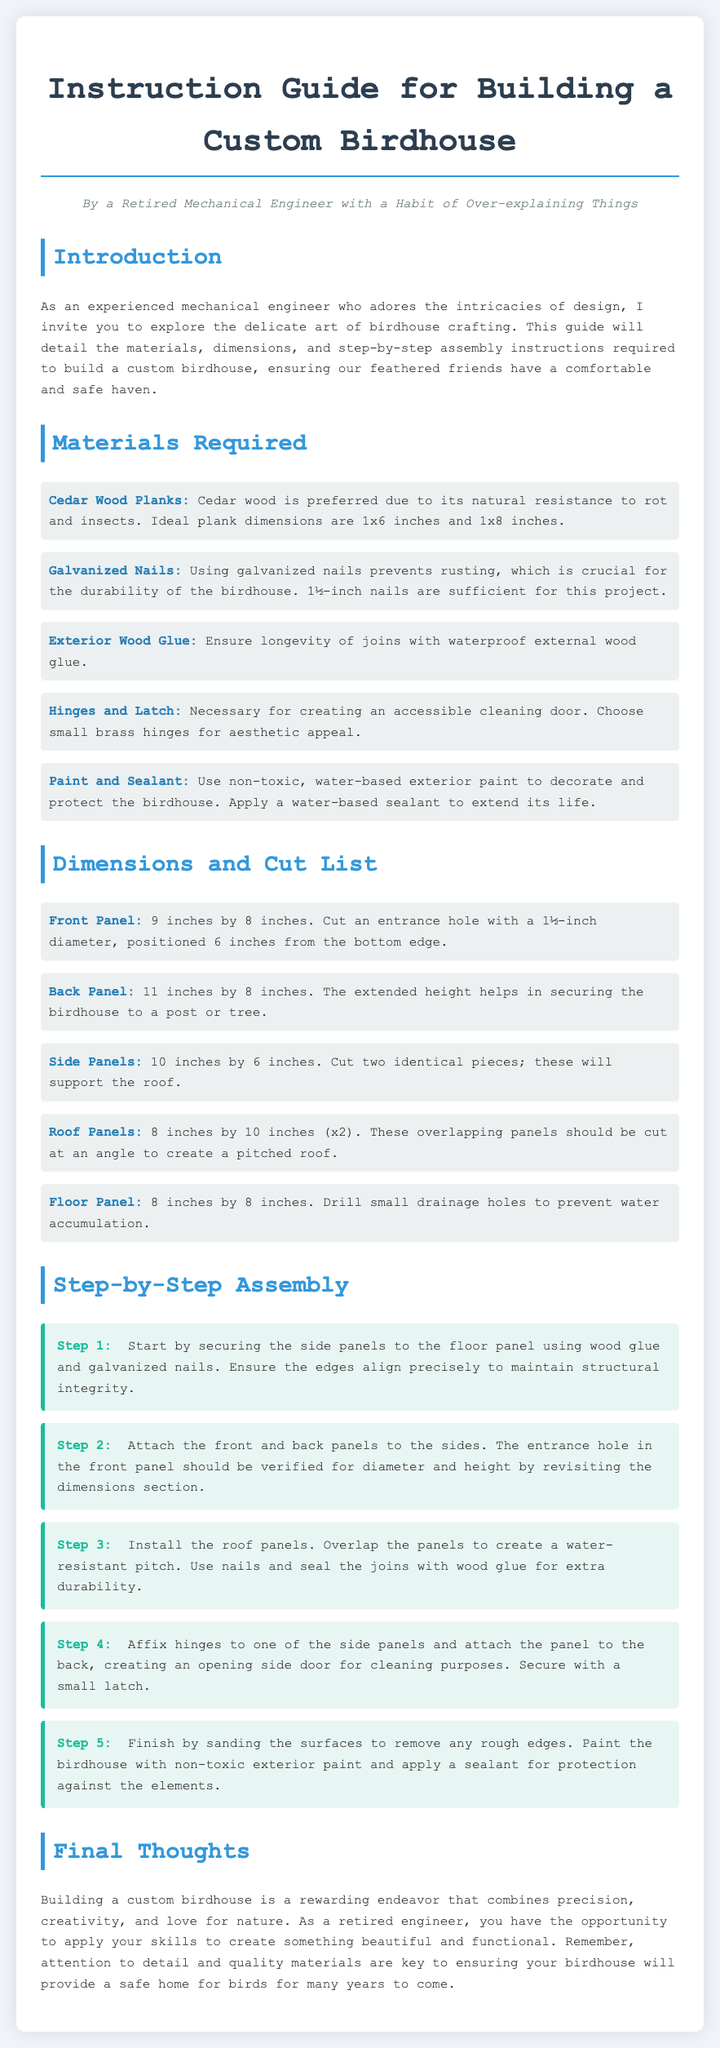what is the recommended wood type for the birdhouse? The document states that cedar wood is preferred due to its natural resistance to rot and insects.
Answer: Cedar Wood Planks how many hinges are suggested for the birdhouse? The guide mentions using small brass hinges for the accessible cleaning door, but does not specify a quantity.
Answer: Hinges what is the diameter of the entrance hole in the front panel? The dimensions section specifies a 1½-inch diameter for the entrance hole in the front panel.
Answer: 1½ inches what is the height of the back panel? According to the dimensions section, the back panel measures 11 inches in height.
Answer: 11 inches what is the first step in the assembly process? The first step involves securing the side panels to the floor panel using wood glue and galvanized nails.
Answer: Securing side panels what is the purpose of the latch mentioned in the materials? The latch is necessary for creating an accessible cleaning door in the birdhouse.
Answer: Cleaning door how many roof panels are required for the birdhouse? The dimensions section indicates that two roof panels are necessary, each measuring 8 inches by 10 inches.
Answer: 2 what is advisable to apply after painting the birdhouse? The guide suggests that a water-based sealant should be applied to extend the life of the birdhouse.
Answer: Sealant how should the roof panels be cut? The assembly instructions explain that the roof panels should be cut at an angle to create a pitched roof.
Answer: Angled 